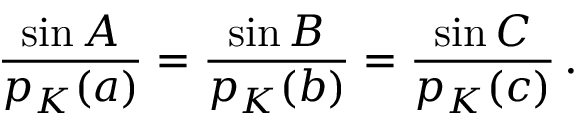Convert formula to latex. <formula><loc_0><loc_0><loc_500><loc_500>{ \frac { \sin A } { p _ { K } ( a ) } } = { \frac { \sin B } { p _ { K } ( b ) } } = { \frac { \sin C } { p _ { K } ( c ) } } \, .</formula> 